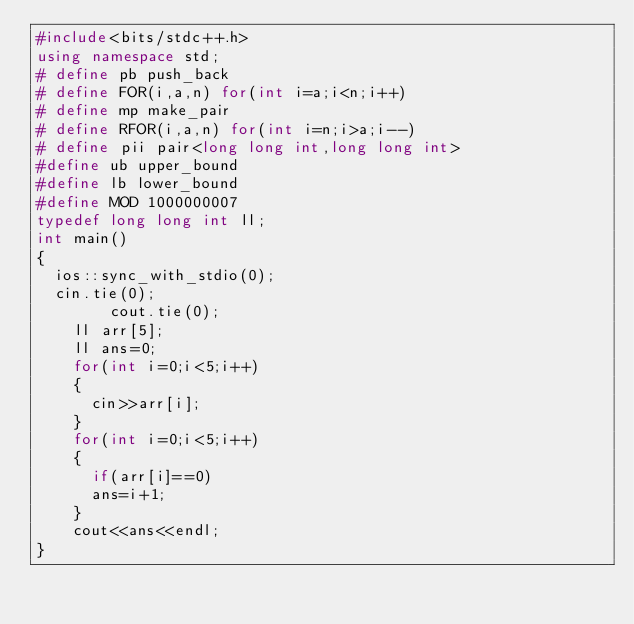<code> <loc_0><loc_0><loc_500><loc_500><_C++_>#include<bits/stdc++.h>
using namespace std;
# define pb push_back
# define FOR(i,a,n) for(int i=a;i<n;i++)
# define mp make_pair
# define RFOR(i,a,n) for(int i=n;i>a;i--)
# define pii pair<long long int,long long int>
#define ub upper_bound
#define lb lower_bound
#define MOD 1000000007
typedef long long int ll;
int main()
{
	ios::sync_with_stdio(0);
	cin.tie(0);
        cout.tie(0);
		ll arr[5];
		ll ans=0;
		for(int i=0;i<5;i++)
		{
			cin>>arr[i];
		}
		for(int i=0;i<5;i++)
		{
			if(arr[i]==0)
			ans=i+1;
		}
		cout<<ans<<endl;
}</code> 